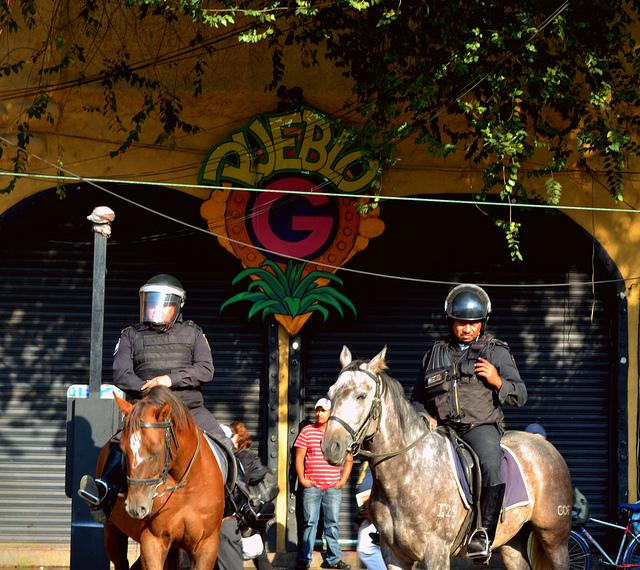What is the profession of the men on horses? police 